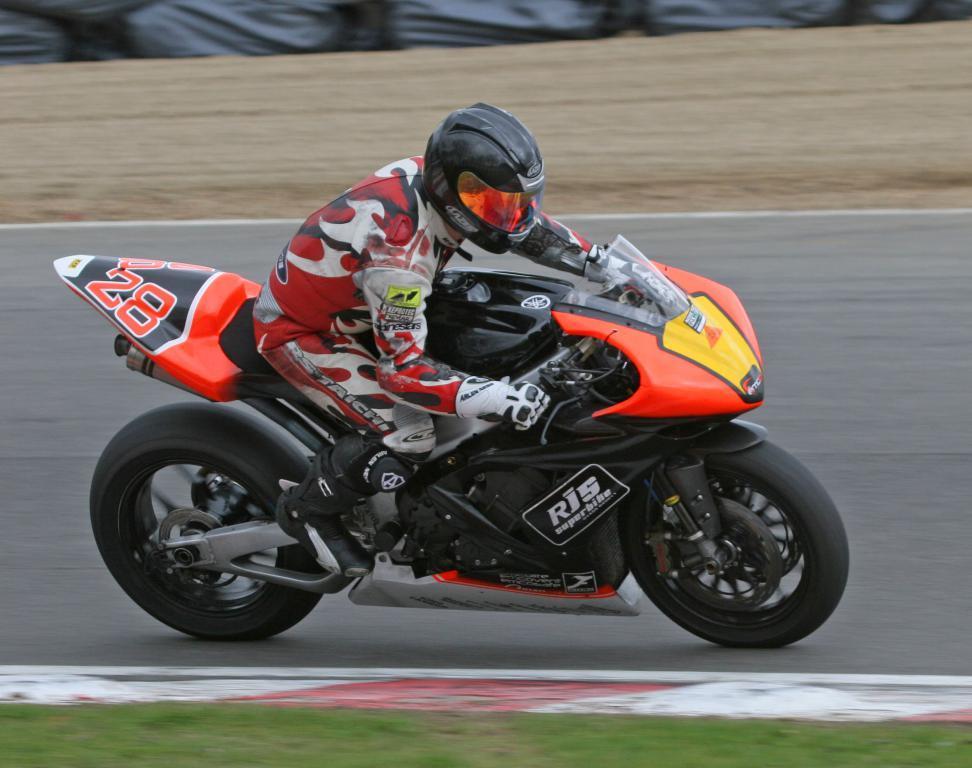Can you describe this image briefly? In this picture we can see a person wearing a helmet and riding on a motor bicycle. There is some text visible on this motor bicycle. We can see some grass on the ground. There are a few objects visible in the background. 